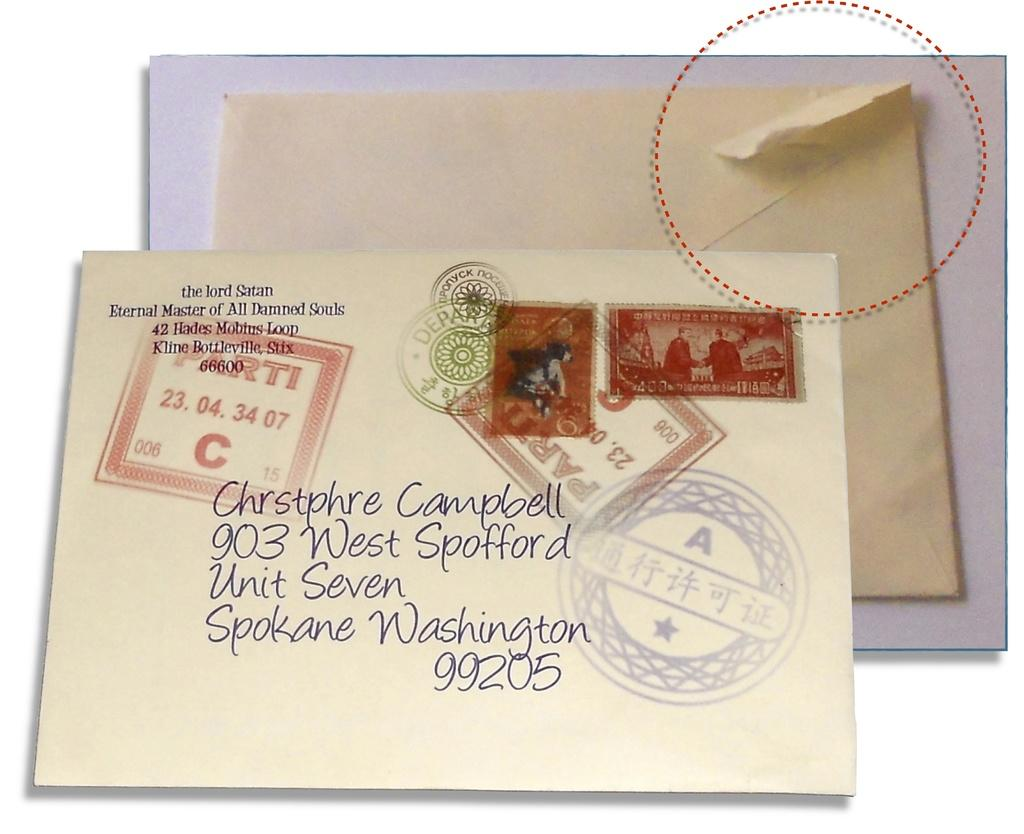Provide a one-sentence caption for the provided image. A letter is addressed to someone in Spokane, Washington. 